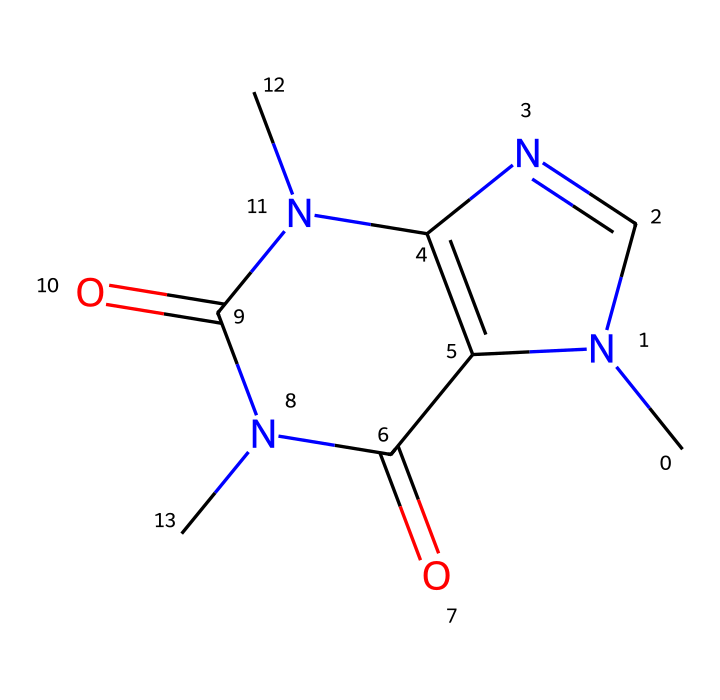What is the molecular formula of caffeine? The SMILES representation can help deduce the molecular formula by counting the different atoms. Here, we see carbon (C), hydrogen (H), nitrogen (N), and oxygen (O) atoms present. The structure indicates 8 carbon atoms, 10 hydrogen atoms, 4 nitrogen atoms, and 2 oxygen atoms. Therefore, the molecular formula is C8H10N4O2.
Answer: C8H10N4O2 How many nitrogen atoms are in the structure of caffeine? By examining the SMILES representation, we can identify the number of nitrogen atoms (N). There are 4 nitrogen symbols present in the structure, indicating four nitrogen atoms in caffeine.
Answer: 4 What type of compound is caffeine classified as? Caffeine contains nitrogen atoms and has a structure that includes rings, specifically a fused bicyclic system which is typical of purines. This classifies caffeine as an alkaloid, which are naturally occurring organic compounds that mostly contain basic nitrogen atoms.
Answer: alkaloid Which functional groups are present in the caffeine molecule? Analyzing the SMILES structure reveals that caffeine contains carbonyl (C=O) groups and amine (N-H) functionalities, which are essential in its classification as an alkaloid. These groups significantly contribute to its properties.
Answer: carbonyl and amine What is the total number of rings in the caffeine structure? The structure of caffeine shows the presence of two interconnected ring systems based on its fused bicyclic structure. This means caffeine has a total of 2 rings.
Answer: 2 What can be inferred about the solubility of caffeine based on its structure? The presence of nitrogen atoms and multiple carbonyl groups typically suggests that caffeine is polar. This polar nature leads to its good solubility in water, a common characteristic for many alkaloids.
Answer: soluble in water How many hydrogen atoms can be found in the caffeine molecular structure? By carefully counting the hydrogen atoms linked to carbon and nitrogen in the SMILES representation, we find that there are 10 hydrogen atoms present in caffeine.
Answer: 10 